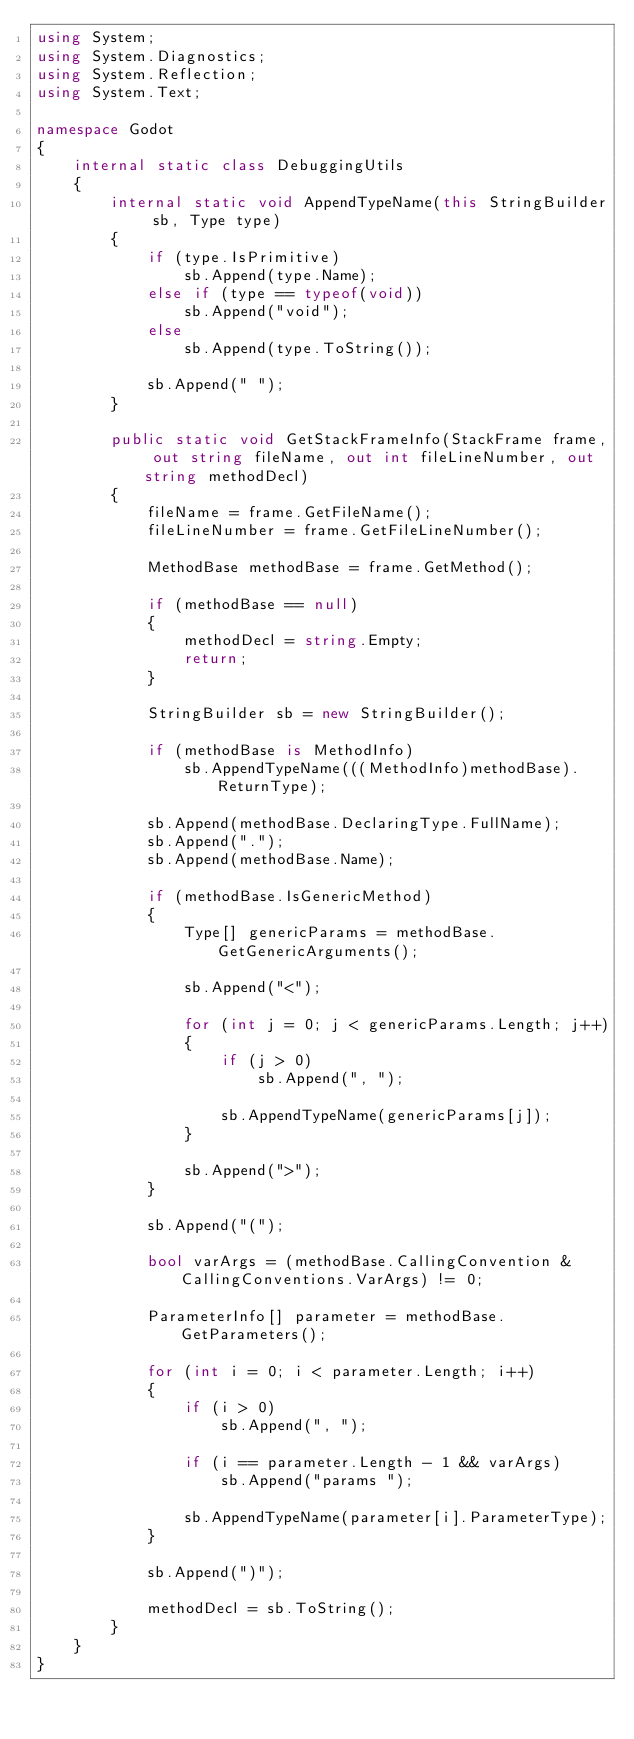<code> <loc_0><loc_0><loc_500><loc_500><_C#_>using System;
using System.Diagnostics;
using System.Reflection;
using System.Text;

namespace Godot
{
    internal static class DebuggingUtils
    {
        internal static void AppendTypeName(this StringBuilder sb, Type type)
        {
            if (type.IsPrimitive)
                sb.Append(type.Name);
            else if (type == typeof(void))
                sb.Append("void");
            else
                sb.Append(type.ToString());

            sb.Append(" ");
        }

        public static void GetStackFrameInfo(StackFrame frame, out string fileName, out int fileLineNumber, out string methodDecl)
        {
            fileName = frame.GetFileName();
            fileLineNumber = frame.GetFileLineNumber();

            MethodBase methodBase = frame.GetMethod();

            if (methodBase == null)
            {
                methodDecl = string.Empty;
                return;
            }

            StringBuilder sb = new StringBuilder();

            if (methodBase is MethodInfo)
                sb.AppendTypeName(((MethodInfo)methodBase).ReturnType);

            sb.Append(methodBase.DeclaringType.FullName);
            sb.Append(".");
            sb.Append(methodBase.Name);

            if (methodBase.IsGenericMethod)
            {
                Type[] genericParams = methodBase.GetGenericArguments();

                sb.Append("<");

                for (int j = 0; j < genericParams.Length; j++)
                {
                    if (j > 0)
                        sb.Append(", ");

                    sb.AppendTypeName(genericParams[j]);
                }

                sb.Append(">");
            }

            sb.Append("(");

            bool varArgs = (methodBase.CallingConvention & CallingConventions.VarArgs) != 0;

            ParameterInfo[] parameter = methodBase.GetParameters();

            for (int i = 0; i < parameter.Length; i++)
            {
                if (i > 0)
                    sb.Append(", ");

                if (i == parameter.Length - 1 && varArgs)
                    sb.Append("params ");

                sb.AppendTypeName(parameter[i].ParameterType);
            }

            sb.Append(")");

            methodDecl = sb.ToString();
        }
    }
}
</code> 